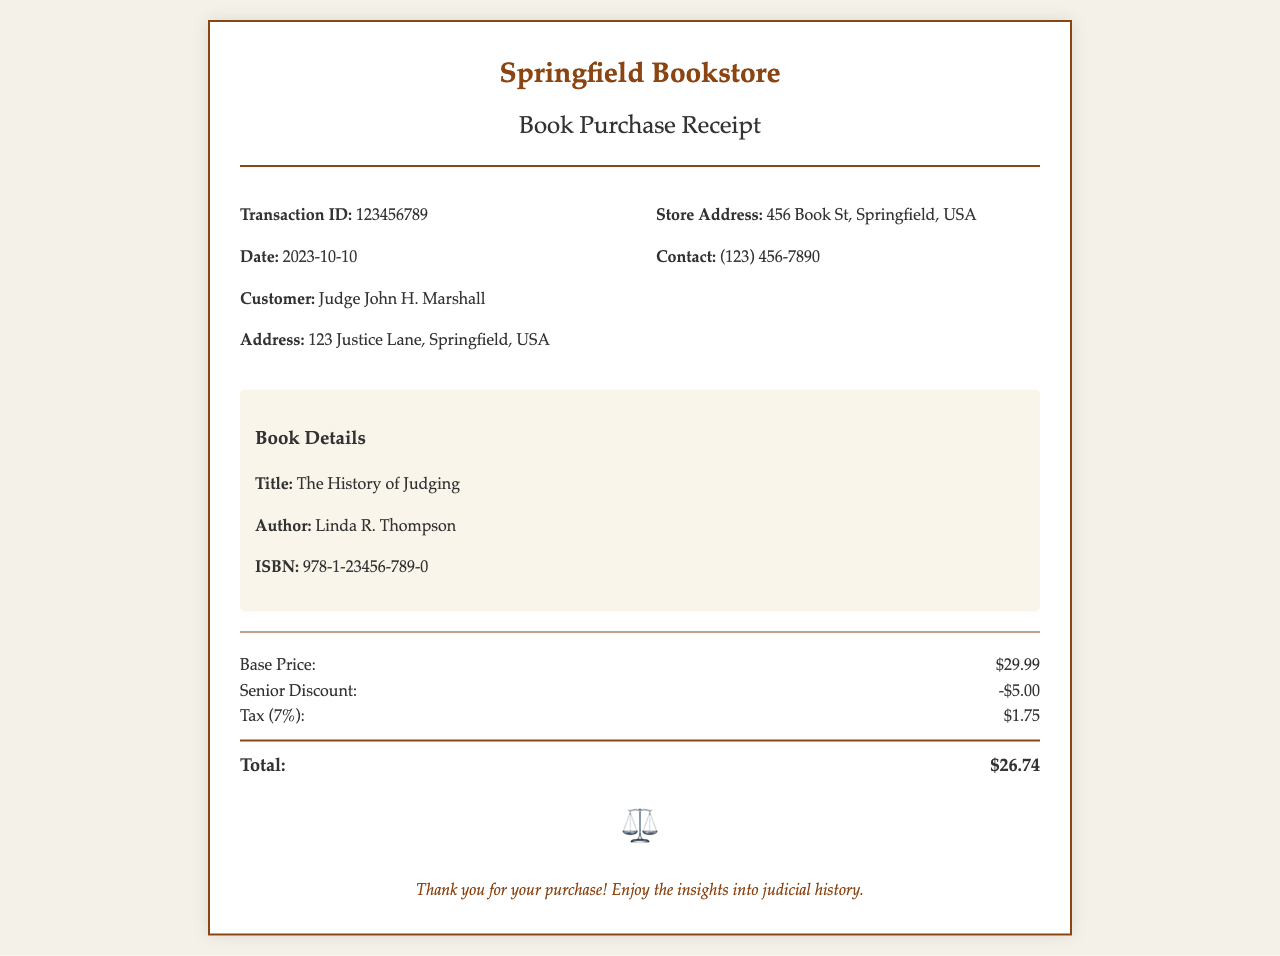What is the title of the book? The title is specifically mentioned under the book details section.
Answer: The History of Judging Who is the author of the book? The author's name is listed in the book details.
Answer: Linda R. Thompson What is the transaction ID? The transaction ID is provided in the transaction details section.
Answer: 123456789 What is the date of the purchase? The date of the purchase is clearly stated in the receipt.
Answer: 2023-10-10 What is the base price of the book? The base price is prominently displayed in the price details section.
Answer: $29.99 What is the total amount paid after discounts and tax? The total amount reflects the calculations of the base price, discounts, and tax mentioned.
Answer: $26.74 What is the amount of the senior discount? The senior discount amount is clearly specified in the price details.
Answer: -$5.00 What is the tax rate applied to the purchase? The tax rate can be inferred from the tax calculation mentioned in the price details.
Answer: 7% Where was the bookstore located? The bookstore address is provided in the details section.
Answer: 456 Book St, Springfield, USA 